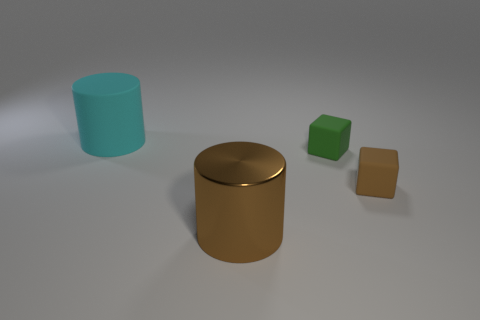Add 2 matte cylinders. How many objects exist? 6 Add 1 tiny blocks. How many tiny blocks exist? 3 Subtract 0 purple spheres. How many objects are left? 4 Subtract all tiny cyan metal things. Subtract all metallic things. How many objects are left? 3 Add 3 green matte cubes. How many green matte cubes are left? 4 